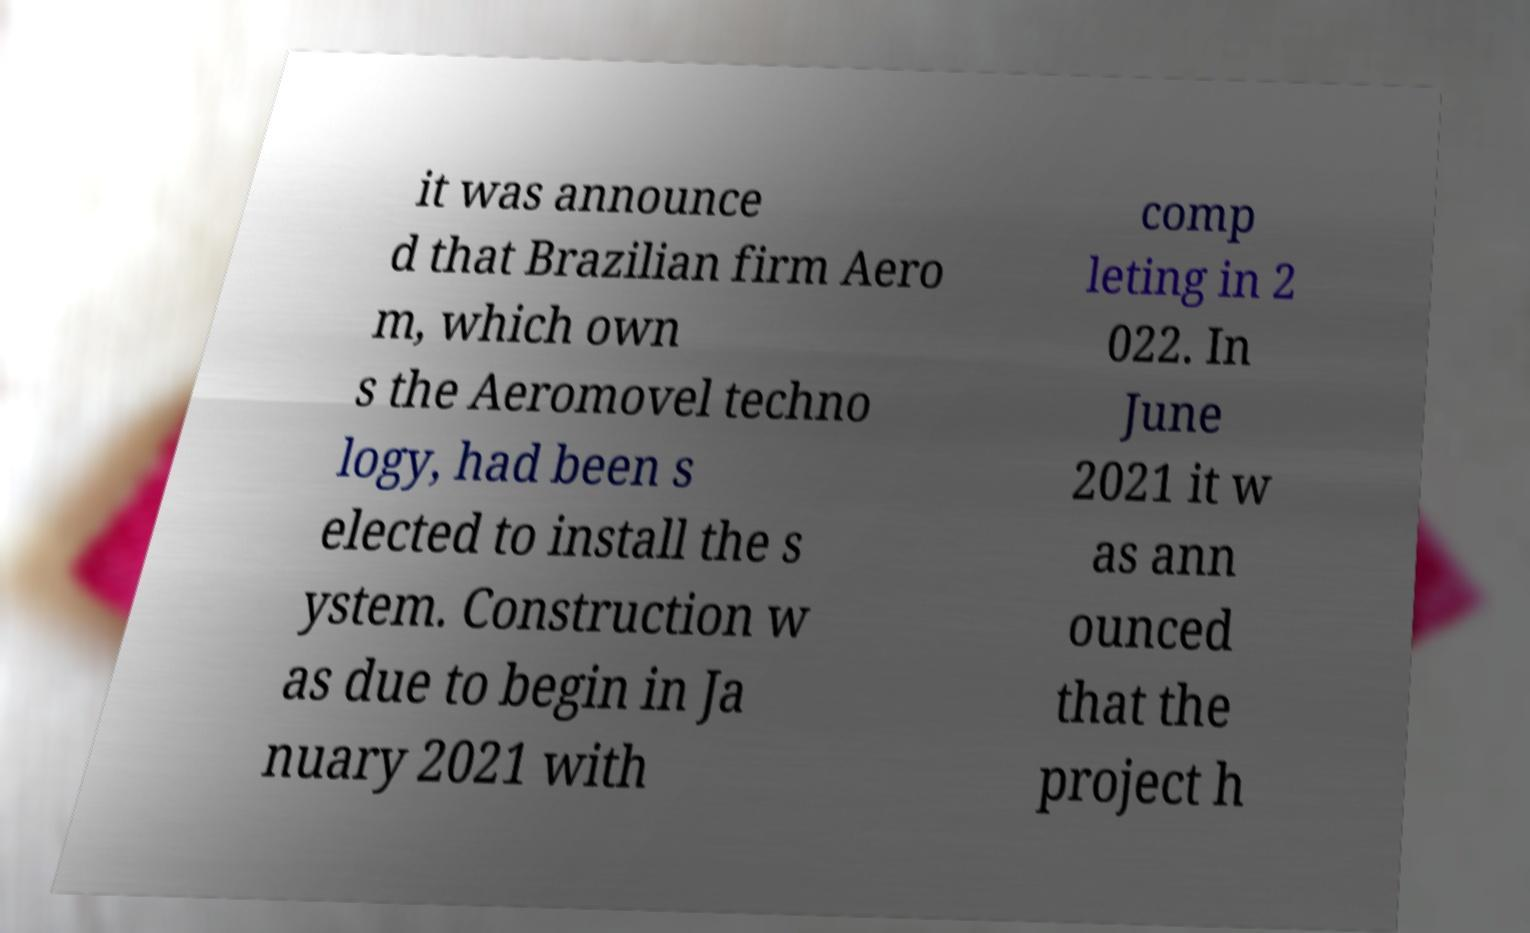I need the written content from this picture converted into text. Can you do that? it was announce d that Brazilian firm Aero m, which own s the Aeromovel techno logy, had been s elected to install the s ystem. Construction w as due to begin in Ja nuary 2021 with comp leting in 2 022. In June 2021 it w as ann ounced that the project h 